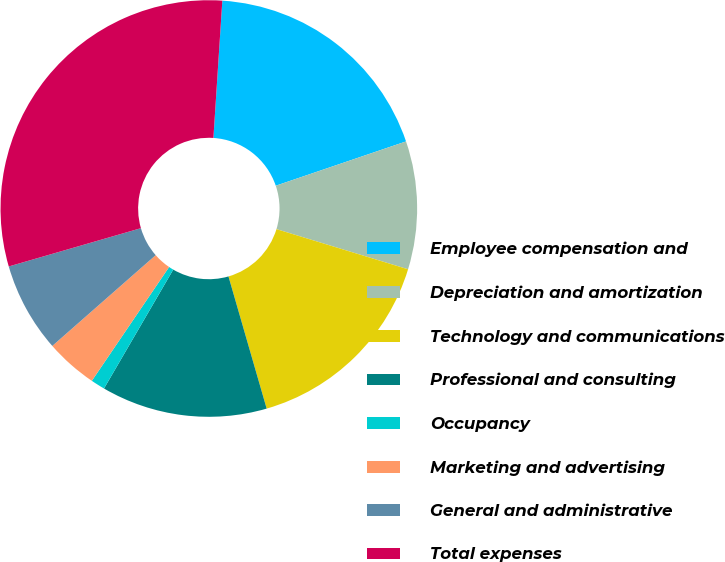<chart> <loc_0><loc_0><loc_500><loc_500><pie_chart><fcel>Employee compensation and<fcel>Depreciation and amortization<fcel>Technology and communications<fcel>Professional and consulting<fcel>Occupancy<fcel>Marketing and advertising<fcel>General and administrative<fcel>Total expenses<nl><fcel>18.75%<fcel>9.93%<fcel>15.81%<fcel>12.87%<fcel>1.1%<fcel>4.04%<fcel>6.98%<fcel>30.52%<nl></chart> 